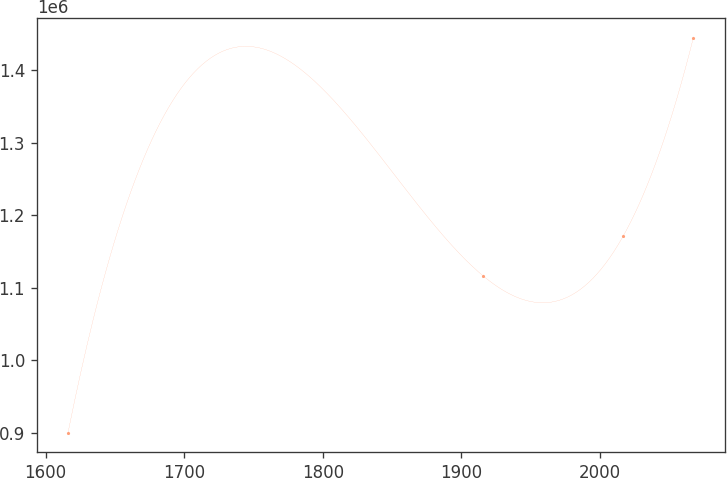Convert chart to OTSL. <chart><loc_0><loc_0><loc_500><loc_500><line_chart><ecel><fcel>Unnamed: 1<nl><fcel>1616.14<fcel>900317<nl><fcel>1915.63<fcel>1.11676e+06<nl><fcel>2016.68<fcel>1.17122e+06<nl><fcel>2067.41<fcel>1.44498e+06<nl></chart> 